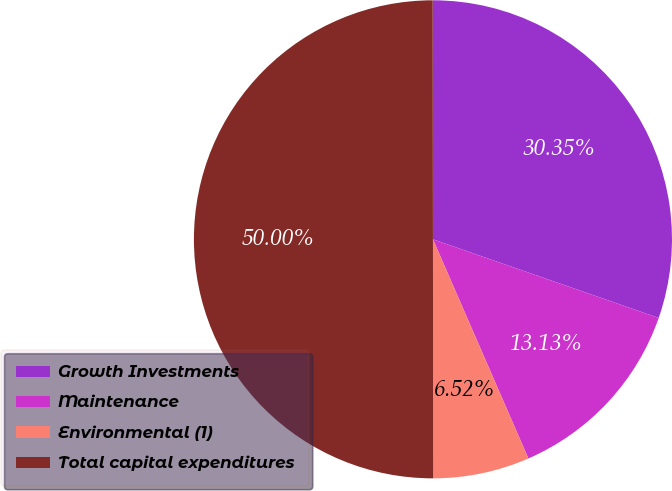Convert chart to OTSL. <chart><loc_0><loc_0><loc_500><loc_500><pie_chart><fcel>Growth Investments<fcel>Maintenance<fcel>Environmental (1)<fcel>Total capital expenditures<nl><fcel>30.35%<fcel>13.13%<fcel>6.52%<fcel>50.0%<nl></chart> 